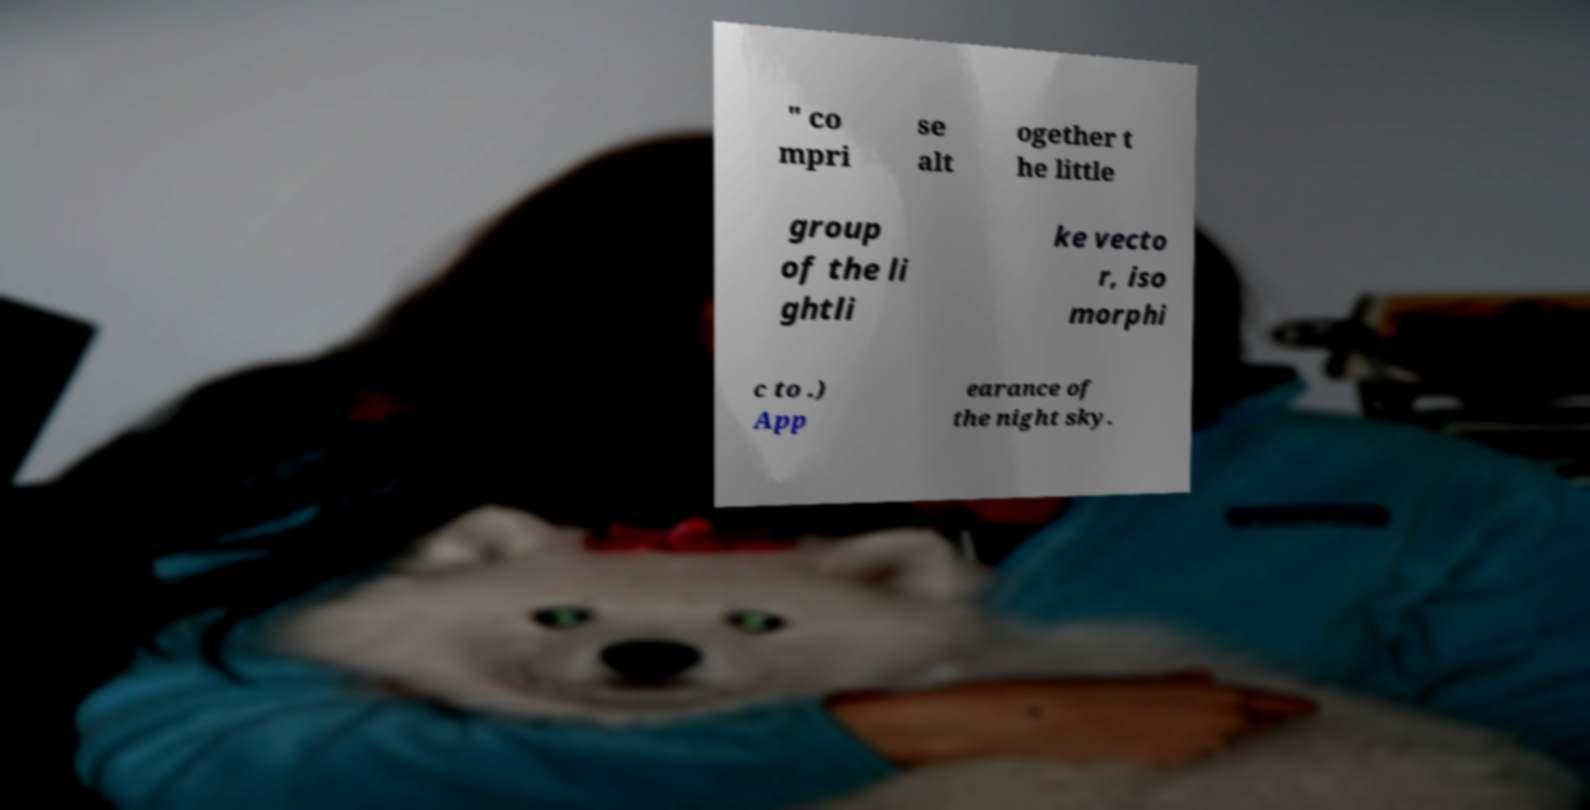Please identify and transcribe the text found in this image. " co mpri se alt ogether t he little group of the li ghtli ke vecto r, iso morphi c to .) App earance of the night sky. 